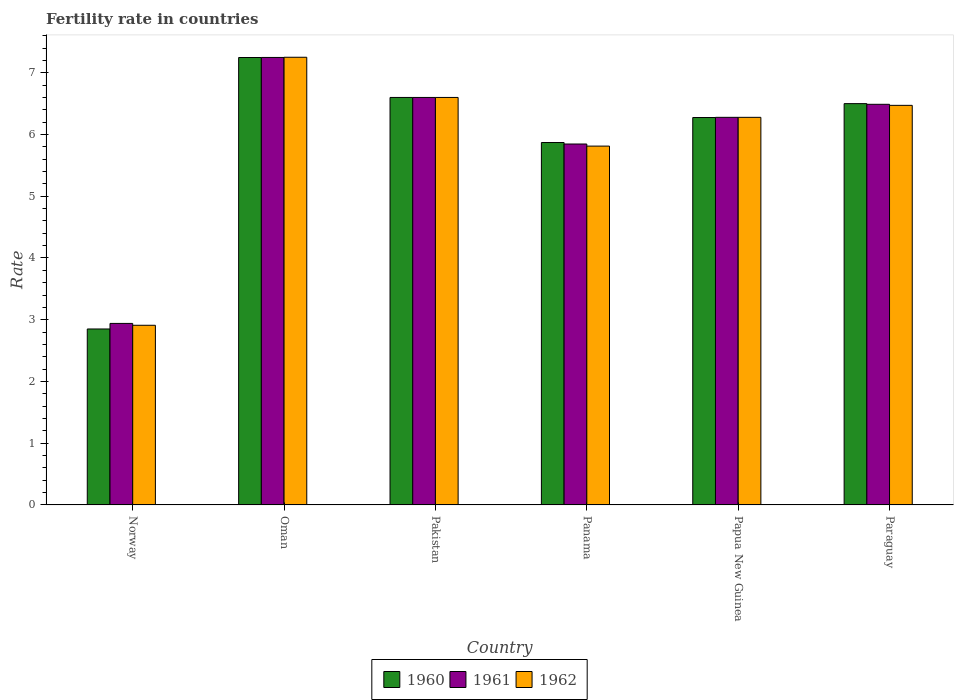How many groups of bars are there?
Offer a terse response. 6. Are the number of bars per tick equal to the number of legend labels?
Offer a terse response. Yes. Are the number of bars on each tick of the X-axis equal?
Offer a terse response. Yes. What is the label of the 4th group of bars from the left?
Your answer should be compact. Panama. In how many cases, is the number of bars for a given country not equal to the number of legend labels?
Your answer should be compact. 0. What is the fertility rate in 1960 in Paraguay?
Ensure brevity in your answer.  6.5. Across all countries, what is the maximum fertility rate in 1962?
Your response must be concise. 7.25. Across all countries, what is the minimum fertility rate in 1960?
Ensure brevity in your answer.  2.85. In which country was the fertility rate in 1960 maximum?
Keep it short and to the point. Oman. In which country was the fertility rate in 1961 minimum?
Provide a short and direct response. Norway. What is the total fertility rate in 1962 in the graph?
Provide a short and direct response. 35.32. What is the difference between the fertility rate in 1962 in Norway and that in Paraguay?
Your answer should be compact. -3.56. What is the difference between the fertility rate in 1960 in Norway and the fertility rate in 1962 in Panama?
Provide a succinct answer. -2.96. What is the average fertility rate in 1960 per country?
Offer a very short reply. 5.89. What is the difference between the fertility rate of/in 1961 and fertility rate of/in 1962 in Oman?
Your answer should be very brief. -0. In how many countries, is the fertility rate in 1960 greater than 6.8?
Offer a very short reply. 1. What is the ratio of the fertility rate in 1960 in Pakistan to that in Papua New Guinea?
Give a very brief answer. 1.05. Is the fertility rate in 1960 in Norway less than that in Papua New Guinea?
Offer a very short reply. Yes. Is the difference between the fertility rate in 1961 in Pakistan and Panama greater than the difference between the fertility rate in 1962 in Pakistan and Panama?
Offer a terse response. No. What is the difference between the highest and the second highest fertility rate in 1961?
Keep it short and to the point. -0.11. What is the difference between the highest and the lowest fertility rate in 1960?
Your answer should be compact. 4.4. Is the sum of the fertility rate in 1960 in Norway and Panama greater than the maximum fertility rate in 1962 across all countries?
Ensure brevity in your answer.  Yes. Is it the case that in every country, the sum of the fertility rate in 1960 and fertility rate in 1961 is greater than the fertility rate in 1962?
Provide a succinct answer. Yes. How many bars are there?
Provide a short and direct response. 18. How many countries are there in the graph?
Your response must be concise. 6. Does the graph contain any zero values?
Provide a short and direct response. No. How many legend labels are there?
Offer a terse response. 3. How are the legend labels stacked?
Provide a succinct answer. Horizontal. What is the title of the graph?
Ensure brevity in your answer.  Fertility rate in countries. What is the label or title of the X-axis?
Your answer should be compact. Country. What is the label or title of the Y-axis?
Make the answer very short. Rate. What is the Rate in 1960 in Norway?
Give a very brief answer. 2.85. What is the Rate of 1961 in Norway?
Your answer should be compact. 2.94. What is the Rate in 1962 in Norway?
Offer a terse response. 2.91. What is the Rate in 1960 in Oman?
Ensure brevity in your answer.  7.25. What is the Rate of 1961 in Oman?
Provide a short and direct response. 7.25. What is the Rate of 1962 in Oman?
Your answer should be compact. 7.25. What is the Rate in 1962 in Pakistan?
Offer a very short reply. 6.6. What is the Rate in 1960 in Panama?
Make the answer very short. 5.87. What is the Rate in 1961 in Panama?
Your response must be concise. 5.85. What is the Rate of 1962 in Panama?
Provide a short and direct response. 5.81. What is the Rate of 1960 in Papua New Guinea?
Make the answer very short. 6.28. What is the Rate in 1961 in Papua New Guinea?
Your answer should be very brief. 6.28. What is the Rate in 1962 in Papua New Guinea?
Keep it short and to the point. 6.28. What is the Rate in 1960 in Paraguay?
Provide a short and direct response. 6.5. What is the Rate of 1961 in Paraguay?
Your response must be concise. 6.49. What is the Rate of 1962 in Paraguay?
Your answer should be very brief. 6.47. Across all countries, what is the maximum Rate in 1960?
Your response must be concise. 7.25. Across all countries, what is the maximum Rate in 1961?
Your response must be concise. 7.25. Across all countries, what is the maximum Rate in 1962?
Your response must be concise. 7.25. Across all countries, what is the minimum Rate of 1960?
Your answer should be very brief. 2.85. Across all countries, what is the minimum Rate in 1961?
Your response must be concise. 2.94. Across all countries, what is the minimum Rate of 1962?
Give a very brief answer. 2.91. What is the total Rate of 1960 in the graph?
Your answer should be compact. 35.34. What is the total Rate in 1961 in the graph?
Give a very brief answer. 35.4. What is the total Rate of 1962 in the graph?
Your answer should be very brief. 35.32. What is the difference between the Rate of 1960 in Norway and that in Oman?
Provide a short and direct response. -4.4. What is the difference between the Rate of 1961 in Norway and that in Oman?
Make the answer very short. -4.31. What is the difference between the Rate in 1962 in Norway and that in Oman?
Offer a very short reply. -4.34. What is the difference between the Rate in 1960 in Norway and that in Pakistan?
Offer a very short reply. -3.75. What is the difference between the Rate of 1961 in Norway and that in Pakistan?
Make the answer very short. -3.66. What is the difference between the Rate of 1962 in Norway and that in Pakistan?
Give a very brief answer. -3.69. What is the difference between the Rate in 1960 in Norway and that in Panama?
Your answer should be very brief. -3.02. What is the difference between the Rate in 1961 in Norway and that in Panama?
Give a very brief answer. -2.91. What is the difference between the Rate of 1962 in Norway and that in Panama?
Your response must be concise. -2.9. What is the difference between the Rate in 1960 in Norway and that in Papua New Guinea?
Provide a succinct answer. -3.42. What is the difference between the Rate of 1961 in Norway and that in Papua New Guinea?
Your response must be concise. -3.34. What is the difference between the Rate in 1962 in Norway and that in Papua New Guinea?
Provide a short and direct response. -3.37. What is the difference between the Rate in 1960 in Norway and that in Paraguay?
Make the answer very short. -3.65. What is the difference between the Rate in 1961 in Norway and that in Paraguay?
Keep it short and to the point. -3.55. What is the difference between the Rate in 1962 in Norway and that in Paraguay?
Your answer should be very brief. -3.56. What is the difference between the Rate of 1960 in Oman and that in Pakistan?
Your answer should be compact. 0.65. What is the difference between the Rate of 1961 in Oman and that in Pakistan?
Provide a short and direct response. 0.65. What is the difference between the Rate in 1962 in Oman and that in Pakistan?
Offer a terse response. 0.65. What is the difference between the Rate of 1960 in Oman and that in Panama?
Your answer should be very brief. 1.38. What is the difference between the Rate in 1961 in Oman and that in Panama?
Your response must be concise. 1.4. What is the difference between the Rate of 1962 in Oman and that in Panama?
Provide a succinct answer. 1.44. What is the difference between the Rate in 1960 in Oman and that in Papua New Guinea?
Offer a terse response. 0.97. What is the difference between the Rate of 1960 in Oman and that in Paraguay?
Offer a very short reply. 0.75. What is the difference between the Rate of 1961 in Oman and that in Paraguay?
Make the answer very short. 0.76. What is the difference between the Rate of 1962 in Oman and that in Paraguay?
Your response must be concise. 0.78. What is the difference between the Rate of 1960 in Pakistan and that in Panama?
Your answer should be very brief. 0.73. What is the difference between the Rate of 1961 in Pakistan and that in Panama?
Keep it short and to the point. 0.75. What is the difference between the Rate in 1962 in Pakistan and that in Panama?
Ensure brevity in your answer.  0.79. What is the difference between the Rate of 1960 in Pakistan and that in Papua New Guinea?
Your answer should be compact. 0.33. What is the difference between the Rate of 1961 in Pakistan and that in Papua New Guinea?
Your answer should be very brief. 0.32. What is the difference between the Rate of 1962 in Pakistan and that in Papua New Guinea?
Offer a very short reply. 0.32. What is the difference between the Rate in 1961 in Pakistan and that in Paraguay?
Your answer should be very brief. 0.11. What is the difference between the Rate of 1962 in Pakistan and that in Paraguay?
Offer a terse response. 0.13. What is the difference between the Rate of 1960 in Panama and that in Papua New Guinea?
Ensure brevity in your answer.  -0.41. What is the difference between the Rate in 1961 in Panama and that in Papua New Guinea?
Offer a terse response. -0.43. What is the difference between the Rate in 1962 in Panama and that in Papua New Guinea?
Your answer should be very brief. -0.47. What is the difference between the Rate in 1960 in Panama and that in Paraguay?
Provide a succinct answer. -0.63. What is the difference between the Rate in 1961 in Panama and that in Paraguay?
Provide a short and direct response. -0.64. What is the difference between the Rate of 1962 in Panama and that in Paraguay?
Make the answer very short. -0.66. What is the difference between the Rate of 1960 in Papua New Guinea and that in Paraguay?
Provide a succinct answer. -0.23. What is the difference between the Rate in 1961 in Papua New Guinea and that in Paraguay?
Offer a very short reply. -0.21. What is the difference between the Rate of 1962 in Papua New Guinea and that in Paraguay?
Your answer should be compact. -0.19. What is the difference between the Rate of 1960 in Norway and the Rate of 1961 in Oman?
Give a very brief answer. -4.4. What is the difference between the Rate of 1960 in Norway and the Rate of 1962 in Oman?
Keep it short and to the point. -4.4. What is the difference between the Rate of 1961 in Norway and the Rate of 1962 in Oman?
Ensure brevity in your answer.  -4.31. What is the difference between the Rate of 1960 in Norway and the Rate of 1961 in Pakistan?
Ensure brevity in your answer.  -3.75. What is the difference between the Rate of 1960 in Norway and the Rate of 1962 in Pakistan?
Your response must be concise. -3.75. What is the difference between the Rate in 1961 in Norway and the Rate in 1962 in Pakistan?
Offer a very short reply. -3.66. What is the difference between the Rate in 1960 in Norway and the Rate in 1961 in Panama?
Your answer should be very brief. -3. What is the difference between the Rate in 1960 in Norway and the Rate in 1962 in Panama?
Your response must be concise. -2.96. What is the difference between the Rate of 1961 in Norway and the Rate of 1962 in Panama?
Your answer should be compact. -2.87. What is the difference between the Rate in 1960 in Norway and the Rate in 1961 in Papua New Guinea?
Make the answer very short. -3.43. What is the difference between the Rate in 1960 in Norway and the Rate in 1962 in Papua New Guinea?
Your answer should be very brief. -3.43. What is the difference between the Rate in 1961 in Norway and the Rate in 1962 in Papua New Guinea?
Provide a short and direct response. -3.34. What is the difference between the Rate in 1960 in Norway and the Rate in 1961 in Paraguay?
Provide a succinct answer. -3.64. What is the difference between the Rate in 1960 in Norway and the Rate in 1962 in Paraguay?
Your answer should be very brief. -3.62. What is the difference between the Rate in 1961 in Norway and the Rate in 1962 in Paraguay?
Give a very brief answer. -3.53. What is the difference between the Rate of 1960 in Oman and the Rate of 1961 in Pakistan?
Provide a short and direct response. 0.65. What is the difference between the Rate in 1960 in Oman and the Rate in 1962 in Pakistan?
Provide a succinct answer. 0.65. What is the difference between the Rate of 1961 in Oman and the Rate of 1962 in Pakistan?
Offer a very short reply. 0.65. What is the difference between the Rate of 1960 in Oman and the Rate of 1961 in Panama?
Provide a succinct answer. 1.4. What is the difference between the Rate in 1960 in Oman and the Rate in 1962 in Panama?
Offer a very short reply. 1.44. What is the difference between the Rate of 1961 in Oman and the Rate of 1962 in Panama?
Provide a succinct answer. 1.44. What is the difference between the Rate in 1961 in Oman and the Rate in 1962 in Papua New Guinea?
Ensure brevity in your answer.  0.97. What is the difference between the Rate of 1960 in Oman and the Rate of 1961 in Paraguay?
Your answer should be compact. 0.76. What is the difference between the Rate of 1960 in Oman and the Rate of 1962 in Paraguay?
Offer a very short reply. 0.78. What is the difference between the Rate of 1961 in Oman and the Rate of 1962 in Paraguay?
Your answer should be very brief. 0.78. What is the difference between the Rate in 1960 in Pakistan and the Rate in 1961 in Panama?
Offer a terse response. 0.75. What is the difference between the Rate of 1960 in Pakistan and the Rate of 1962 in Panama?
Make the answer very short. 0.79. What is the difference between the Rate in 1961 in Pakistan and the Rate in 1962 in Panama?
Your answer should be compact. 0.79. What is the difference between the Rate of 1960 in Pakistan and the Rate of 1961 in Papua New Guinea?
Your answer should be compact. 0.32. What is the difference between the Rate in 1960 in Pakistan and the Rate in 1962 in Papua New Guinea?
Keep it short and to the point. 0.32. What is the difference between the Rate in 1961 in Pakistan and the Rate in 1962 in Papua New Guinea?
Provide a succinct answer. 0.32. What is the difference between the Rate in 1960 in Pakistan and the Rate in 1961 in Paraguay?
Make the answer very short. 0.11. What is the difference between the Rate of 1960 in Pakistan and the Rate of 1962 in Paraguay?
Keep it short and to the point. 0.13. What is the difference between the Rate in 1961 in Pakistan and the Rate in 1962 in Paraguay?
Your response must be concise. 0.13. What is the difference between the Rate in 1960 in Panama and the Rate in 1961 in Papua New Guinea?
Keep it short and to the point. -0.41. What is the difference between the Rate in 1960 in Panama and the Rate in 1962 in Papua New Guinea?
Give a very brief answer. -0.41. What is the difference between the Rate in 1961 in Panama and the Rate in 1962 in Papua New Guinea?
Your answer should be compact. -0.43. What is the difference between the Rate of 1960 in Panama and the Rate of 1961 in Paraguay?
Your answer should be very brief. -0.62. What is the difference between the Rate of 1960 in Panama and the Rate of 1962 in Paraguay?
Your response must be concise. -0.6. What is the difference between the Rate of 1961 in Panama and the Rate of 1962 in Paraguay?
Your answer should be compact. -0.63. What is the difference between the Rate in 1960 in Papua New Guinea and the Rate in 1961 in Paraguay?
Ensure brevity in your answer.  -0.21. What is the difference between the Rate of 1960 in Papua New Guinea and the Rate of 1962 in Paraguay?
Provide a succinct answer. -0.2. What is the difference between the Rate of 1961 in Papua New Guinea and the Rate of 1962 in Paraguay?
Provide a short and direct response. -0.19. What is the average Rate in 1960 per country?
Your answer should be compact. 5.89. What is the average Rate of 1961 per country?
Offer a terse response. 5.9. What is the average Rate of 1962 per country?
Ensure brevity in your answer.  5.89. What is the difference between the Rate in 1960 and Rate in 1961 in Norway?
Provide a short and direct response. -0.09. What is the difference between the Rate in 1960 and Rate in 1962 in Norway?
Make the answer very short. -0.06. What is the difference between the Rate of 1961 and Rate of 1962 in Norway?
Your response must be concise. 0.03. What is the difference between the Rate of 1960 and Rate of 1961 in Oman?
Provide a succinct answer. -0. What is the difference between the Rate of 1960 and Rate of 1962 in Oman?
Offer a terse response. -0. What is the difference between the Rate in 1961 and Rate in 1962 in Oman?
Offer a terse response. -0. What is the difference between the Rate of 1960 and Rate of 1961 in Panama?
Provide a succinct answer. 0.02. What is the difference between the Rate in 1960 and Rate in 1962 in Panama?
Your response must be concise. 0.06. What is the difference between the Rate in 1961 and Rate in 1962 in Panama?
Provide a succinct answer. 0.03. What is the difference between the Rate in 1960 and Rate in 1961 in Papua New Guinea?
Your answer should be very brief. -0. What is the difference between the Rate in 1960 and Rate in 1962 in Papua New Guinea?
Ensure brevity in your answer.  -0. What is the difference between the Rate of 1961 and Rate of 1962 in Papua New Guinea?
Give a very brief answer. 0. What is the difference between the Rate in 1960 and Rate in 1961 in Paraguay?
Offer a terse response. 0.01. What is the difference between the Rate in 1960 and Rate in 1962 in Paraguay?
Keep it short and to the point. 0.03. What is the difference between the Rate in 1961 and Rate in 1962 in Paraguay?
Make the answer very short. 0.02. What is the ratio of the Rate in 1960 in Norway to that in Oman?
Your answer should be compact. 0.39. What is the ratio of the Rate in 1961 in Norway to that in Oman?
Your response must be concise. 0.41. What is the ratio of the Rate of 1962 in Norway to that in Oman?
Provide a short and direct response. 0.4. What is the ratio of the Rate in 1960 in Norway to that in Pakistan?
Provide a short and direct response. 0.43. What is the ratio of the Rate of 1961 in Norway to that in Pakistan?
Keep it short and to the point. 0.45. What is the ratio of the Rate in 1962 in Norway to that in Pakistan?
Keep it short and to the point. 0.44. What is the ratio of the Rate in 1960 in Norway to that in Panama?
Ensure brevity in your answer.  0.49. What is the ratio of the Rate in 1961 in Norway to that in Panama?
Your response must be concise. 0.5. What is the ratio of the Rate of 1962 in Norway to that in Panama?
Provide a short and direct response. 0.5. What is the ratio of the Rate in 1960 in Norway to that in Papua New Guinea?
Provide a succinct answer. 0.45. What is the ratio of the Rate in 1961 in Norway to that in Papua New Guinea?
Your response must be concise. 0.47. What is the ratio of the Rate in 1962 in Norway to that in Papua New Guinea?
Offer a very short reply. 0.46. What is the ratio of the Rate of 1960 in Norway to that in Paraguay?
Provide a short and direct response. 0.44. What is the ratio of the Rate of 1961 in Norway to that in Paraguay?
Offer a terse response. 0.45. What is the ratio of the Rate of 1962 in Norway to that in Paraguay?
Your response must be concise. 0.45. What is the ratio of the Rate in 1960 in Oman to that in Pakistan?
Your answer should be very brief. 1.1. What is the ratio of the Rate of 1961 in Oman to that in Pakistan?
Your response must be concise. 1.1. What is the ratio of the Rate in 1962 in Oman to that in Pakistan?
Make the answer very short. 1.1. What is the ratio of the Rate in 1960 in Oman to that in Panama?
Offer a terse response. 1.23. What is the ratio of the Rate in 1961 in Oman to that in Panama?
Keep it short and to the point. 1.24. What is the ratio of the Rate of 1962 in Oman to that in Panama?
Make the answer very short. 1.25. What is the ratio of the Rate in 1960 in Oman to that in Papua New Guinea?
Ensure brevity in your answer.  1.15. What is the ratio of the Rate of 1961 in Oman to that in Papua New Guinea?
Ensure brevity in your answer.  1.15. What is the ratio of the Rate in 1962 in Oman to that in Papua New Guinea?
Your answer should be compact. 1.16. What is the ratio of the Rate in 1960 in Oman to that in Paraguay?
Your response must be concise. 1.11. What is the ratio of the Rate of 1961 in Oman to that in Paraguay?
Provide a succinct answer. 1.12. What is the ratio of the Rate in 1962 in Oman to that in Paraguay?
Offer a terse response. 1.12. What is the ratio of the Rate of 1960 in Pakistan to that in Panama?
Give a very brief answer. 1.12. What is the ratio of the Rate of 1961 in Pakistan to that in Panama?
Ensure brevity in your answer.  1.13. What is the ratio of the Rate in 1962 in Pakistan to that in Panama?
Keep it short and to the point. 1.14. What is the ratio of the Rate in 1960 in Pakistan to that in Papua New Guinea?
Provide a short and direct response. 1.05. What is the ratio of the Rate of 1961 in Pakistan to that in Papua New Guinea?
Provide a succinct answer. 1.05. What is the ratio of the Rate of 1962 in Pakistan to that in Papua New Guinea?
Offer a terse response. 1.05. What is the ratio of the Rate of 1960 in Pakistan to that in Paraguay?
Make the answer very short. 1.02. What is the ratio of the Rate in 1961 in Pakistan to that in Paraguay?
Provide a short and direct response. 1.02. What is the ratio of the Rate of 1962 in Pakistan to that in Paraguay?
Offer a very short reply. 1.02. What is the ratio of the Rate in 1960 in Panama to that in Papua New Guinea?
Your response must be concise. 0.94. What is the ratio of the Rate in 1961 in Panama to that in Papua New Guinea?
Your response must be concise. 0.93. What is the ratio of the Rate of 1962 in Panama to that in Papua New Guinea?
Provide a short and direct response. 0.93. What is the ratio of the Rate in 1960 in Panama to that in Paraguay?
Provide a short and direct response. 0.9. What is the ratio of the Rate of 1961 in Panama to that in Paraguay?
Keep it short and to the point. 0.9. What is the ratio of the Rate in 1962 in Panama to that in Paraguay?
Provide a succinct answer. 0.9. What is the ratio of the Rate of 1960 in Papua New Guinea to that in Paraguay?
Your response must be concise. 0.97. What is the ratio of the Rate in 1961 in Papua New Guinea to that in Paraguay?
Your response must be concise. 0.97. What is the ratio of the Rate in 1962 in Papua New Guinea to that in Paraguay?
Provide a succinct answer. 0.97. What is the difference between the highest and the second highest Rate of 1960?
Give a very brief answer. 0.65. What is the difference between the highest and the second highest Rate of 1961?
Your response must be concise. 0.65. What is the difference between the highest and the second highest Rate in 1962?
Your answer should be very brief. 0.65. What is the difference between the highest and the lowest Rate in 1960?
Offer a terse response. 4.4. What is the difference between the highest and the lowest Rate in 1961?
Offer a terse response. 4.31. What is the difference between the highest and the lowest Rate of 1962?
Keep it short and to the point. 4.34. 